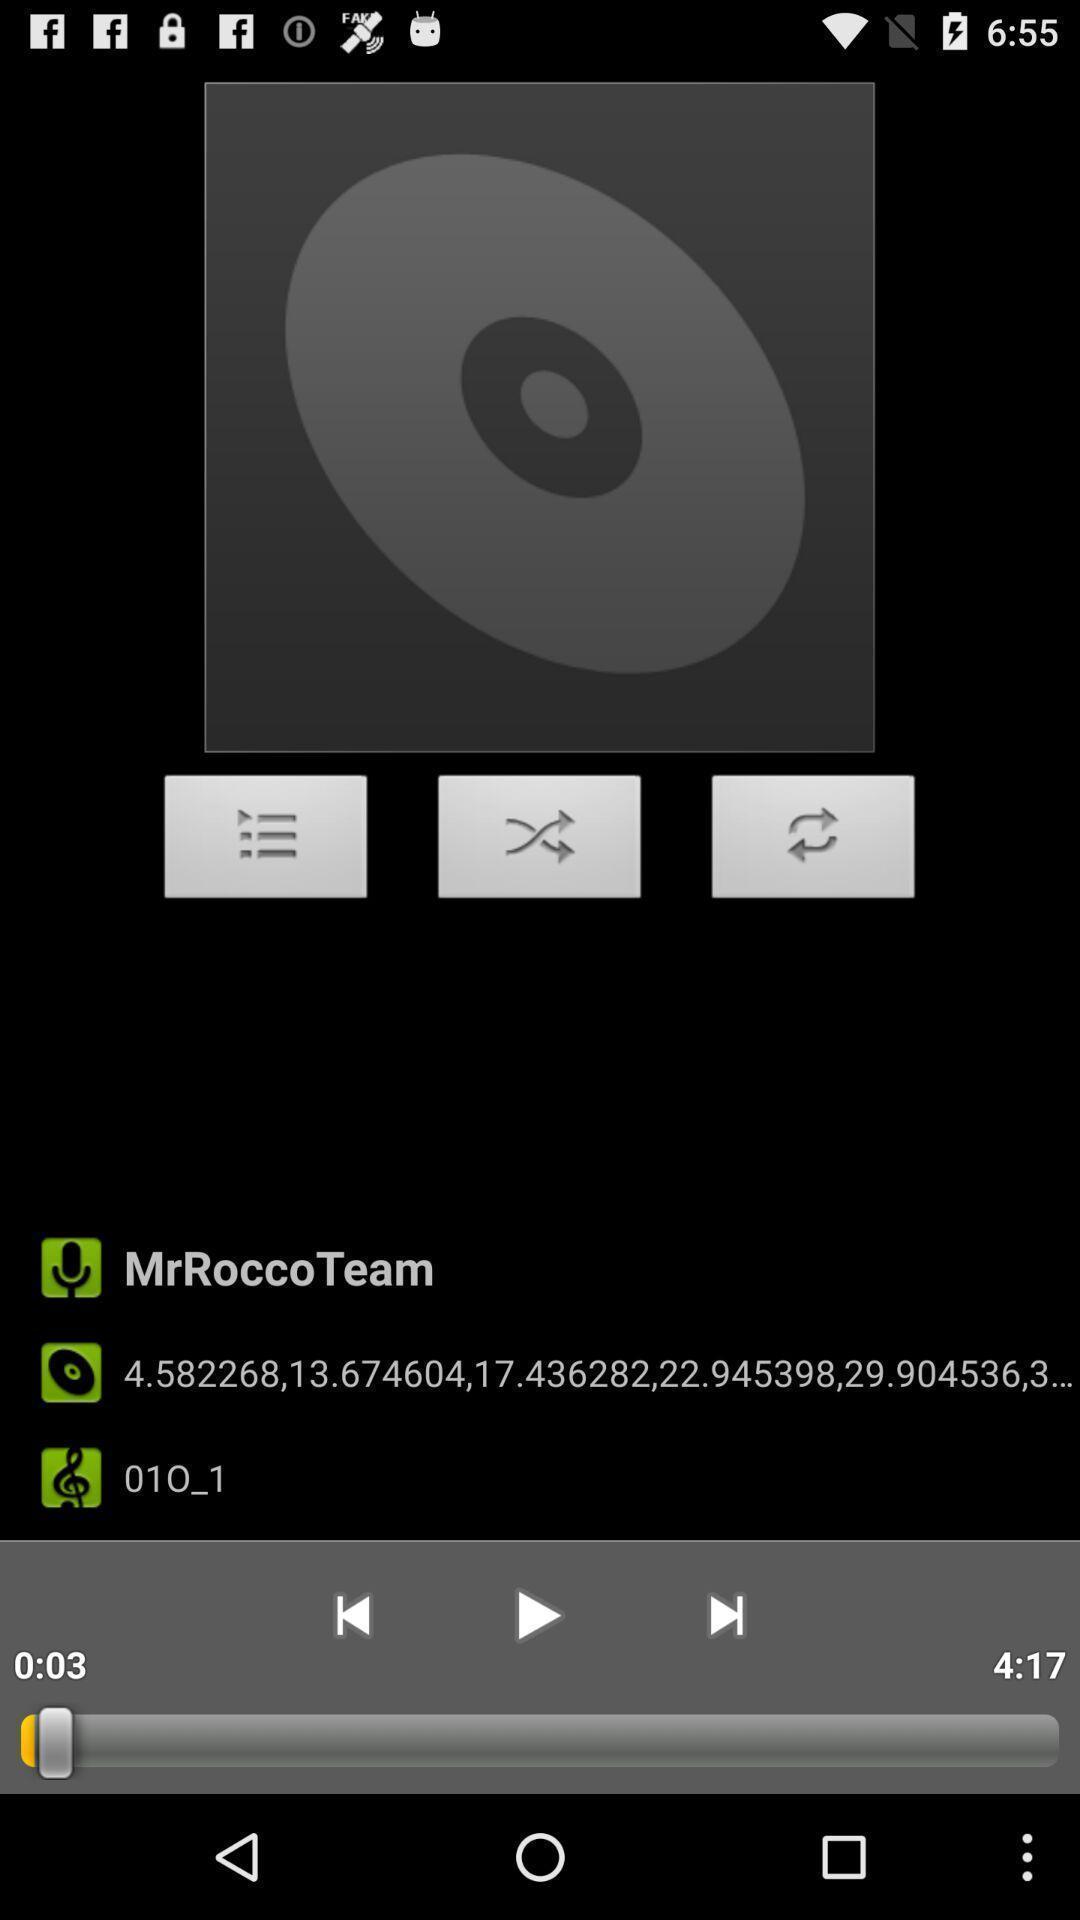Describe the key features of this screenshot. Various options for music player app. 